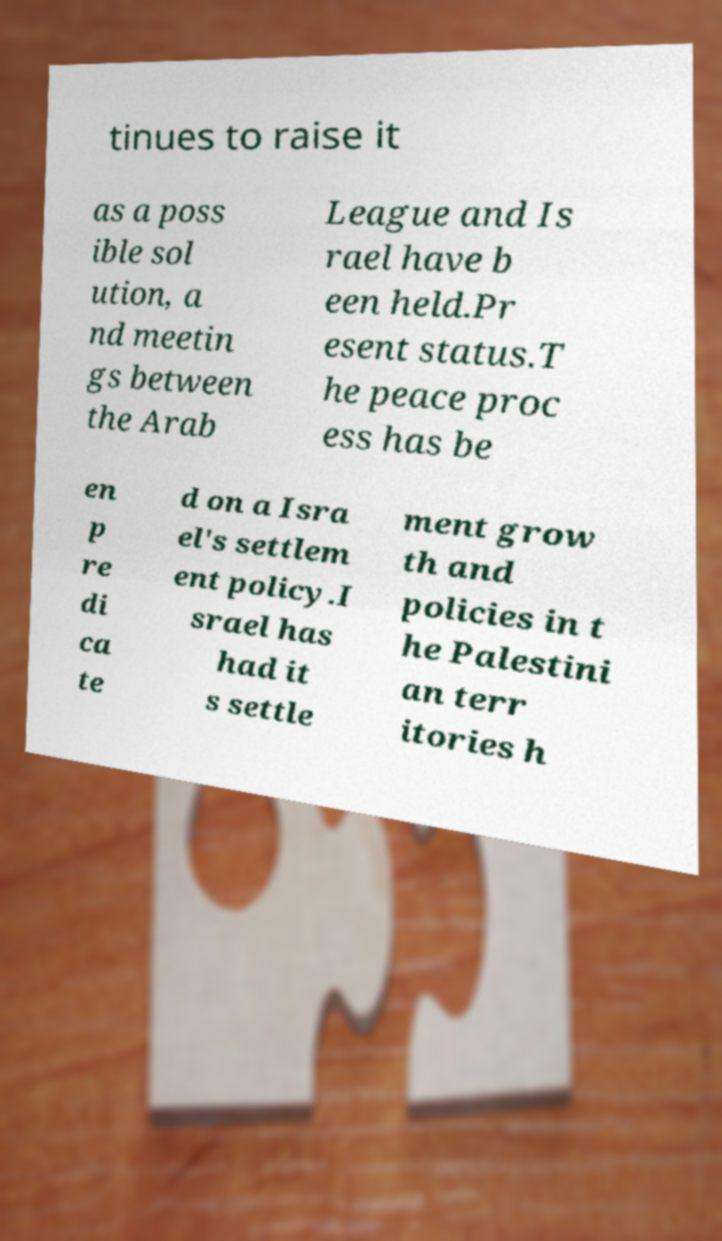There's text embedded in this image that I need extracted. Can you transcribe it verbatim? tinues to raise it as a poss ible sol ution, a nd meetin gs between the Arab League and Is rael have b een held.Pr esent status.T he peace proc ess has be en p re di ca te d on a Isra el's settlem ent policy.I srael has had it s settle ment grow th and policies in t he Palestini an terr itories h 